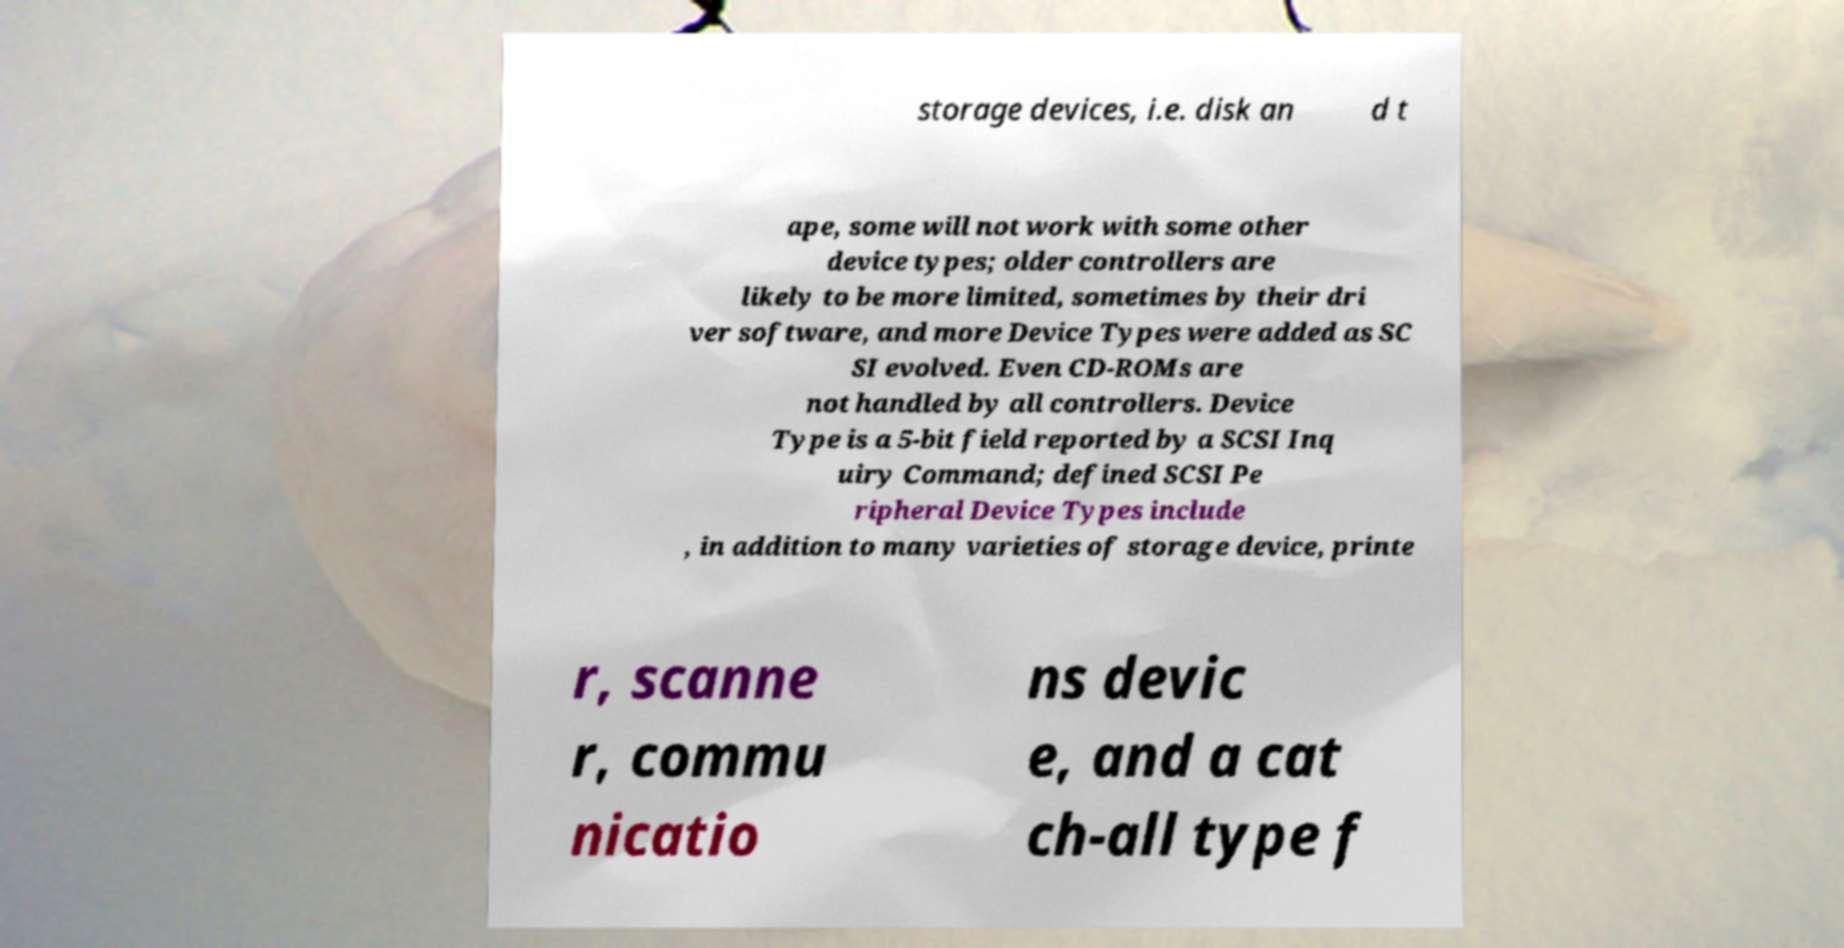Could you assist in decoding the text presented in this image and type it out clearly? storage devices, i.e. disk an d t ape, some will not work with some other device types; older controllers are likely to be more limited, sometimes by their dri ver software, and more Device Types were added as SC SI evolved. Even CD-ROMs are not handled by all controllers. Device Type is a 5-bit field reported by a SCSI Inq uiry Command; defined SCSI Pe ripheral Device Types include , in addition to many varieties of storage device, printe r, scanne r, commu nicatio ns devic e, and a cat ch-all type f 